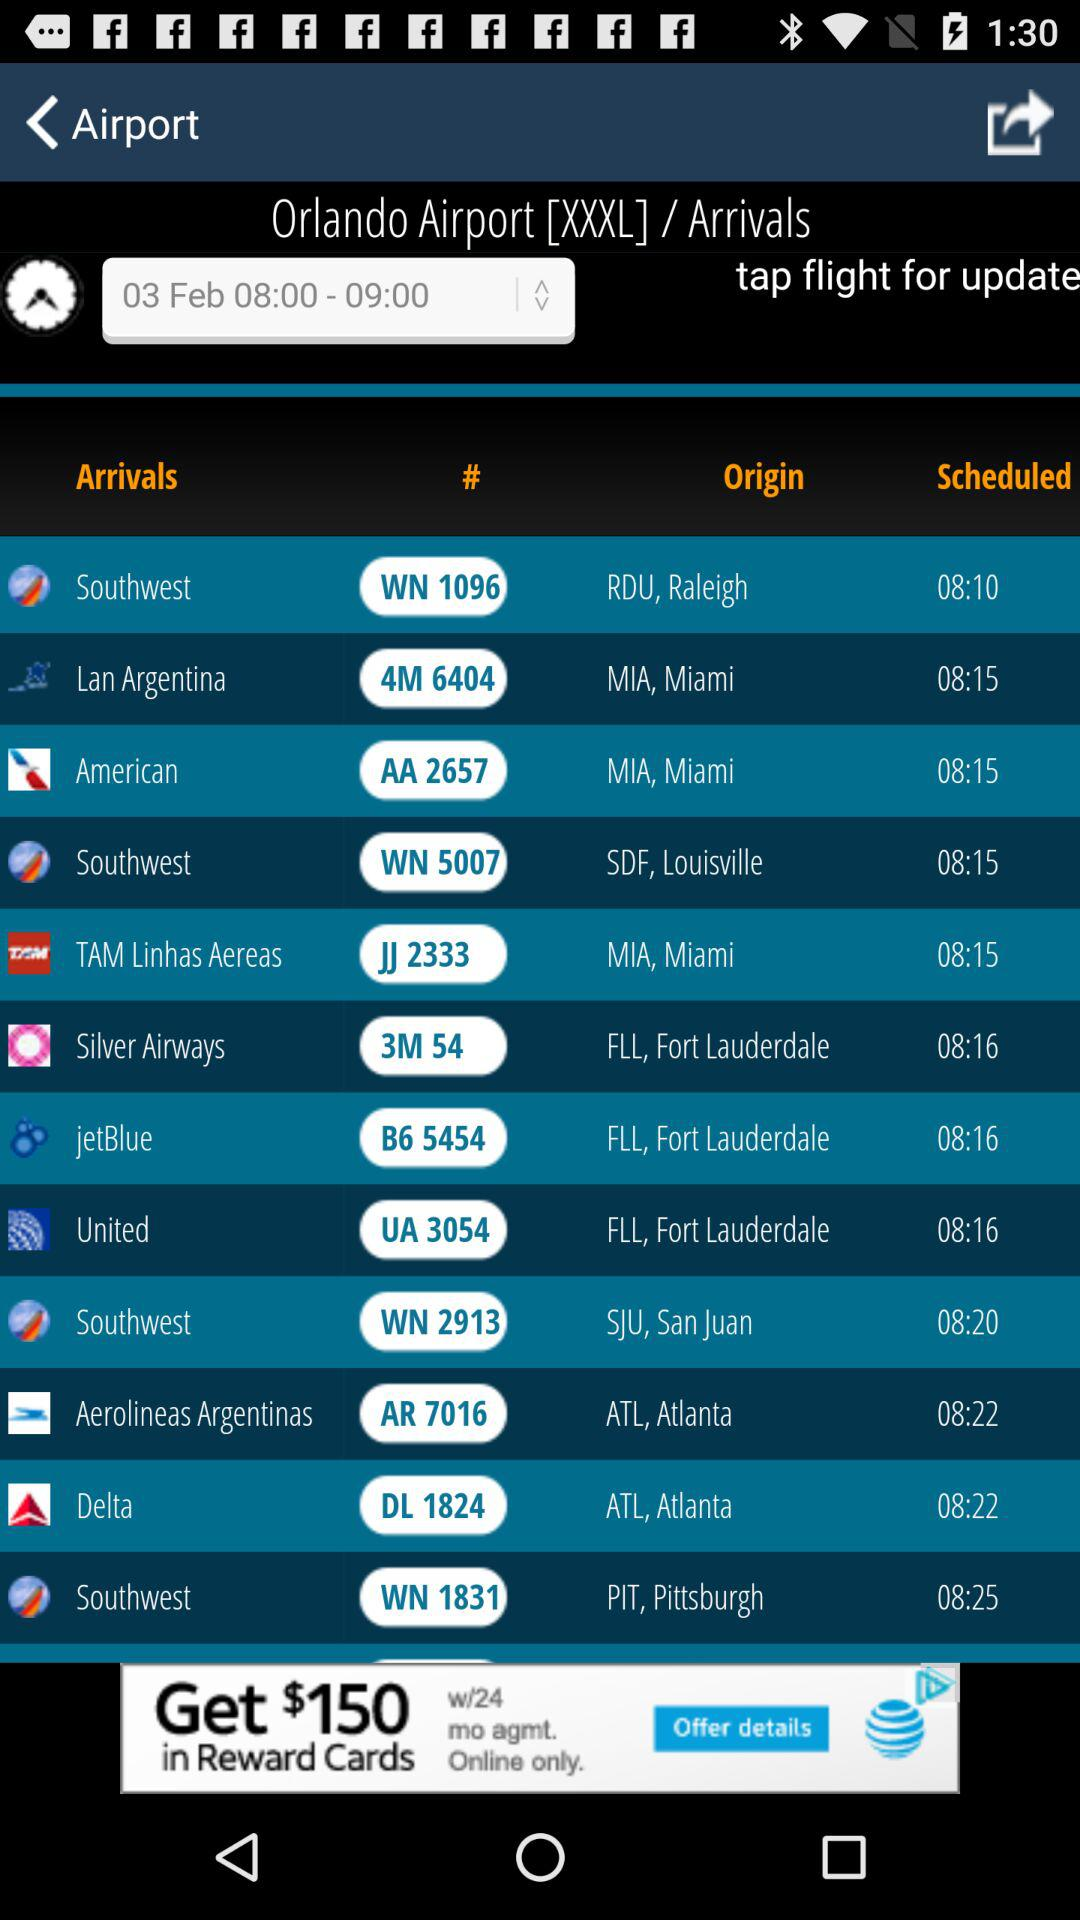What airline has ID WN 1831? The airline is Southwest. 